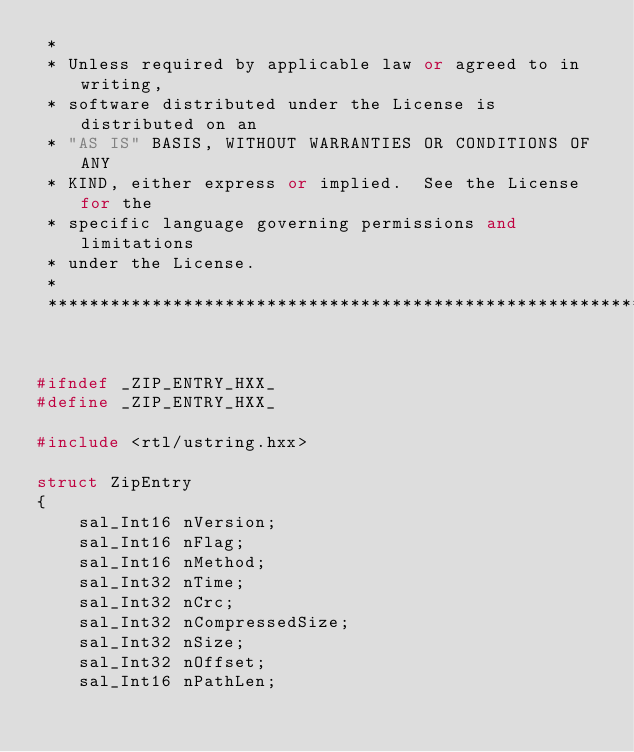Convert code to text. <code><loc_0><loc_0><loc_500><loc_500><_C++_> * 
 * Unless required by applicable law or agreed to in writing,
 * software distributed under the License is distributed on an
 * "AS IS" BASIS, WITHOUT WARRANTIES OR CONDITIONS OF ANY
 * KIND, either express or implied.  See the License for the
 * specific language governing permissions and limitations
 * under the License.
 * 
 *************************************************************/


#ifndef _ZIP_ENTRY_HXX_
#define _ZIP_ENTRY_HXX_

#include <rtl/ustring.hxx>

struct ZipEntry
{
    sal_Int16 nVersion;
    sal_Int16 nFlag;
    sal_Int16 nMethod;
    sal_Int32 nTime;
    sal_Int32 nCrc;
    sal_Int32 nCompressedSize;
    sal_Int32 nSize;
    sal_Int32 nOffset;
    sal_Int16 nPathLen;</code> 